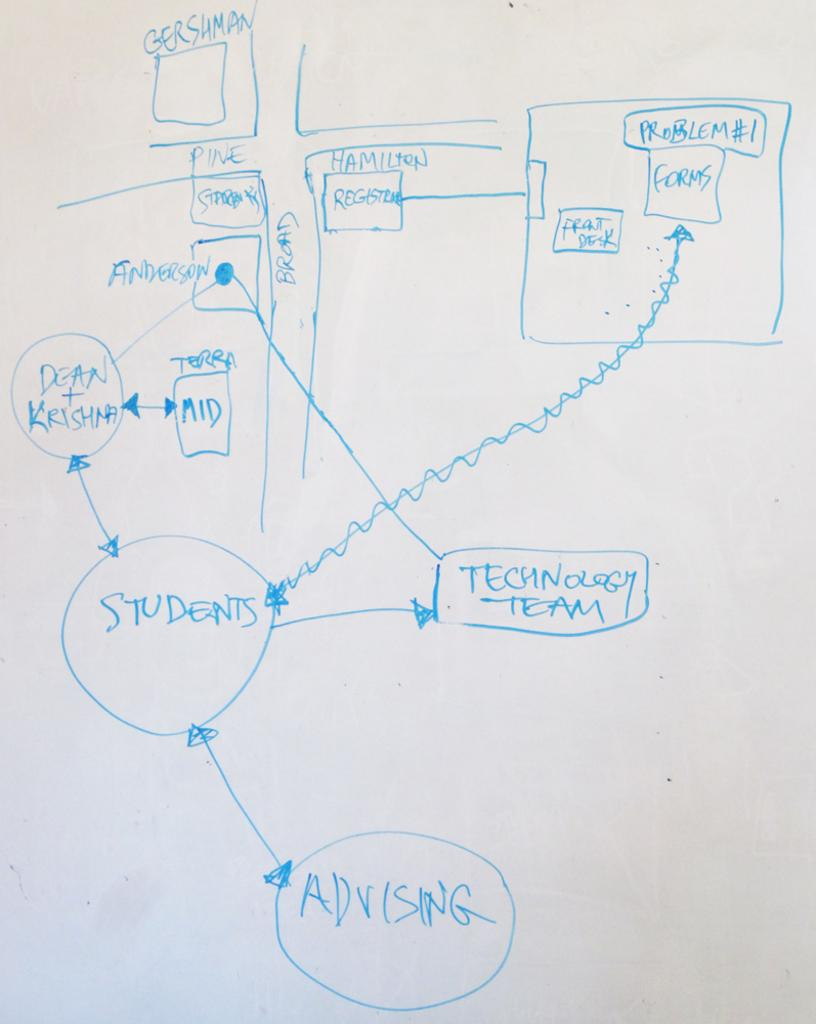<image>
Offer a succinct explanation of the picture presented. A drawing of the intersection of Pine and Broad and that shows what happens in the buildings around there. 